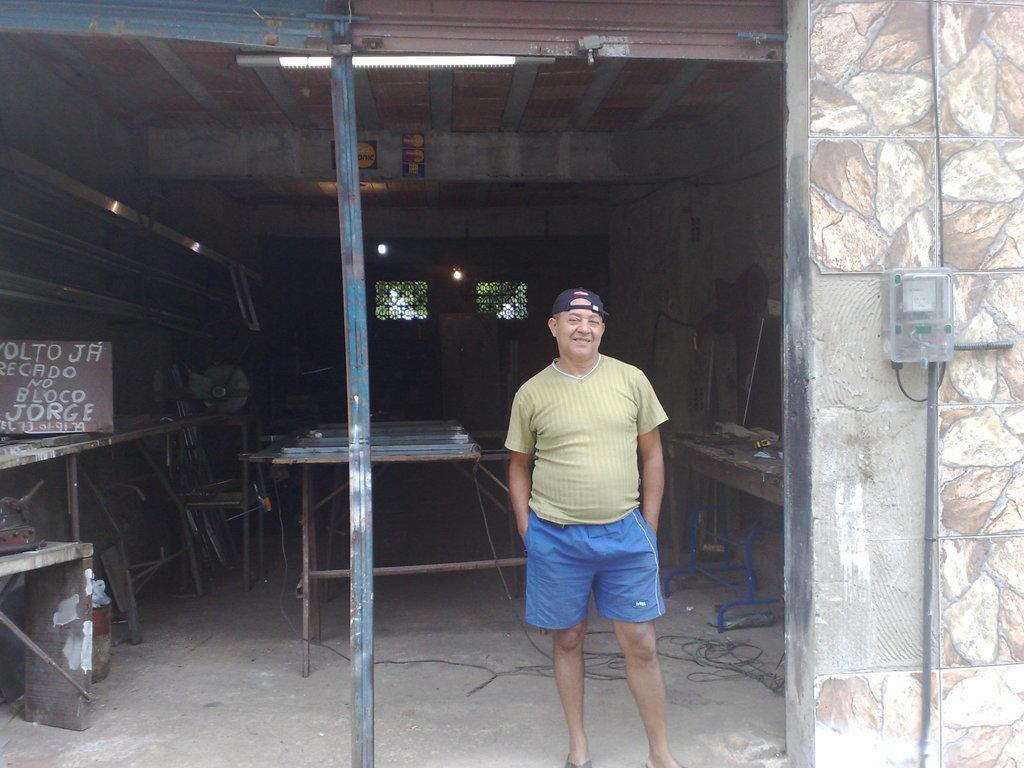<image>
Present a compact description of the photo's key features. A man stands in an open garage by a sign that says no Bloco Jorge. 